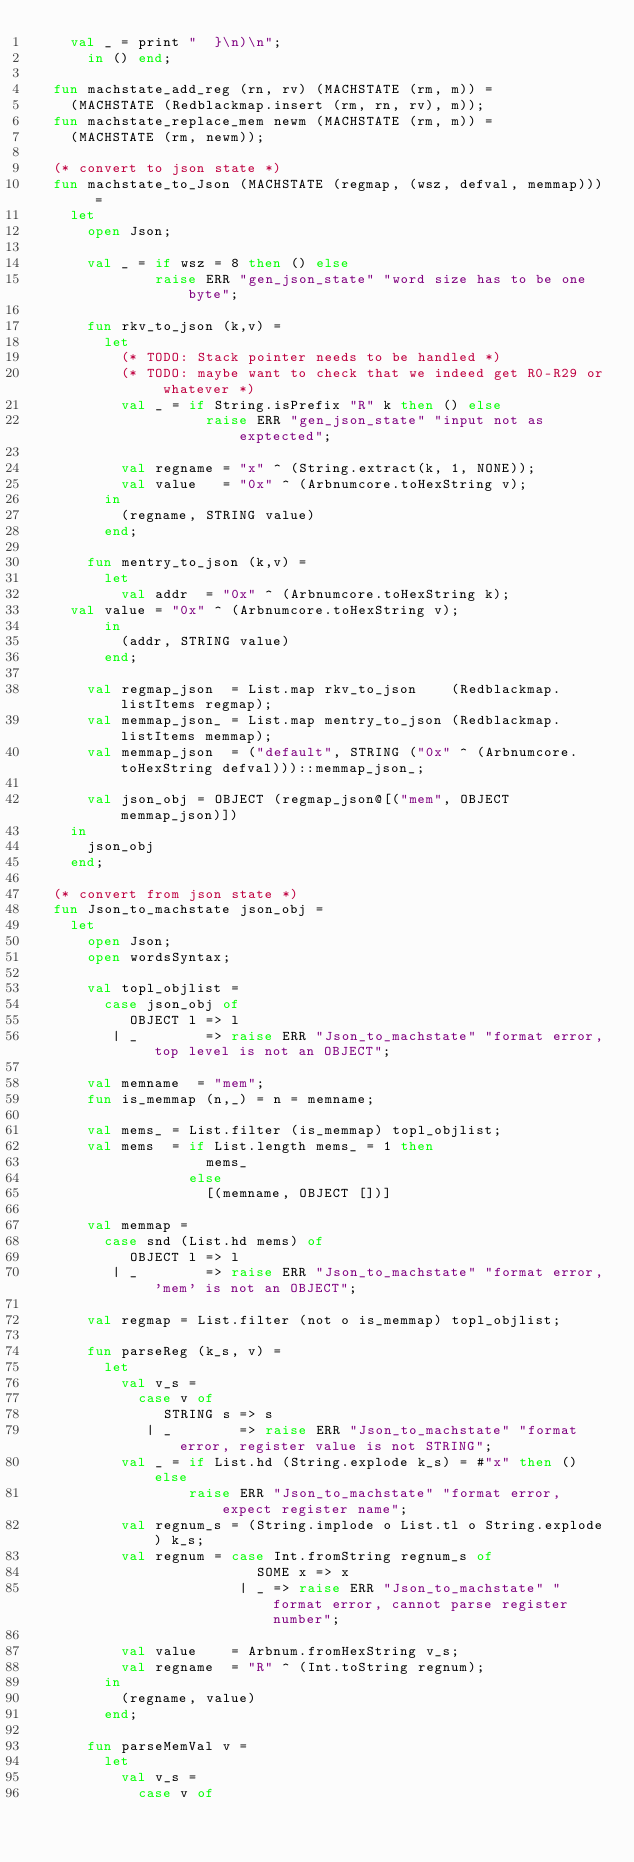Convert code to text. <code><loc_0><loc_0><loc_500><loc_500><_SML_>	  val _ = print "  }\n)\n";
      in () end;

  fun machstate_add_reg (rn, rv) (MACHSTATE (rm, m)) =
    (MACHSTATE (Redblackmap.insert (rm, rn, rv), m));
  fun machstate_replace_mem newm (MACHSTATE (rm, m)) =
    (MACHSTATE (rm, newm));

  (* convert to json state *)
  fun machstate_to_Json (MACHSTATE (regmap, (wsz, defval, memmap))) =
    let
      open Json;

      val _ = if wsz = 8 then () else
              raise ERR "gen_json_state" "word size has to be one byte";

      fun rkv_to_json (k,v) =
        let
          (* TODO: Stack pointer needs to be handled *)
          (* TODO: maybe want to check that we indeed get R0-R29 or whatever *) 
          val _ = if String.isPrefix "R" k then () else
                    raise ERR "gen_json_state" "input not as exptected";

          val regname = "x" ^ (String.extract(k, 1, NONE));
          val value   = "0x" ^ (Arbnumcore.toHexString v);
        in
          (regname, STRING value)
        end;

      fun mentry_to_json (k,v) =
        let
          val addr  = "0x" ^ (Arbnumcore.toHexString k);
	  val value = "0x" ^ (Arbnumcore.toHexString v);
        in
          (addr, STRING value)
        end;

      val regmap_json  = List.map rkv_to_json    (Redblackmap.listItems regmap);
      val memmap_json_ = List.map mentry_to_json (Redblackmap.listItems memmap);
      val memmap_json  = ("default", STRING ("0x" ^ (Arbnumcore.toHexString defval)))::memmap_json_;

      val json_obj = OBJECT (regmap_json@[("mem", OBJECT memmap_json)])
    in
      json_obj
    end;

  (* convert from json state *)
  fun Json_to_machstate json_obj =
    let
      open Json;
      open wordsSyntax;

      val topl_objlist =
        case json_obj of
           OBJECT l => l
         | _        => raise ERR "Json_to_machstate" "format error, top level is not an OBJECT";

      val memname  = "mem";
      fun is_memmap (n,_) = n = memname;

      val mems_ = List.filter (is_memmap) topl_objlist;
      val mems  = if List.length mems_ = 1 then
                    mems_
                  else
                    [(memname, OBJECT [])]

      val memmap =
        case snd (List.hd mems) of
           OBJECT l => l
         | _        => raise ERR "Json_to_machstate" "format error, 'mem' is not an OBJECT";

      val regmap = List.filter (not o is_memmap) topl_objlist;

      fun parseReg (k_s, v) =
        let
          val v_s =
            case v of
               STRING s => s
             | _        => raise ERR "Json_to_machstate" "format error, register value is not STRING";
          val _ = if List.hd (String.explode k_s) = #"x" then () else
                  raise ERR "Json_to_machstate" "format error, expect register name";
          val regnum_s = (String.implode o List.tl o String.explode) k_s;
          val regnum = case Int.fromString regnum_s of
                          SOME x => x
                        | _ => raise ERR "Json_to_machstate" "format error, cannot parse register number";

          val value    = Arbnum.fromHexString v_s;
          val regname  = "R" ^ (Int.toString regnum);
        in
          (regname, value)
        end;

      fun parseMemVal v =
        let
          val v_s =
            case v of</code> 